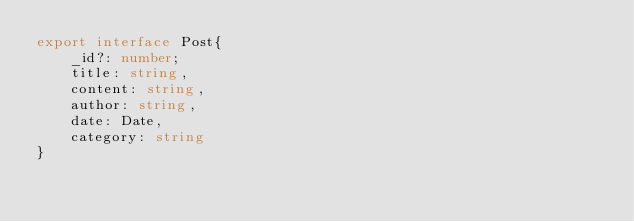<code> <loc_0><loc_0><loc_500><loc_500><_TypeScript_>export interface Post{
    _id?: number;
    title: string,
    content: string,
    author: string,
    date: Date,
    category: string
}
</code> 